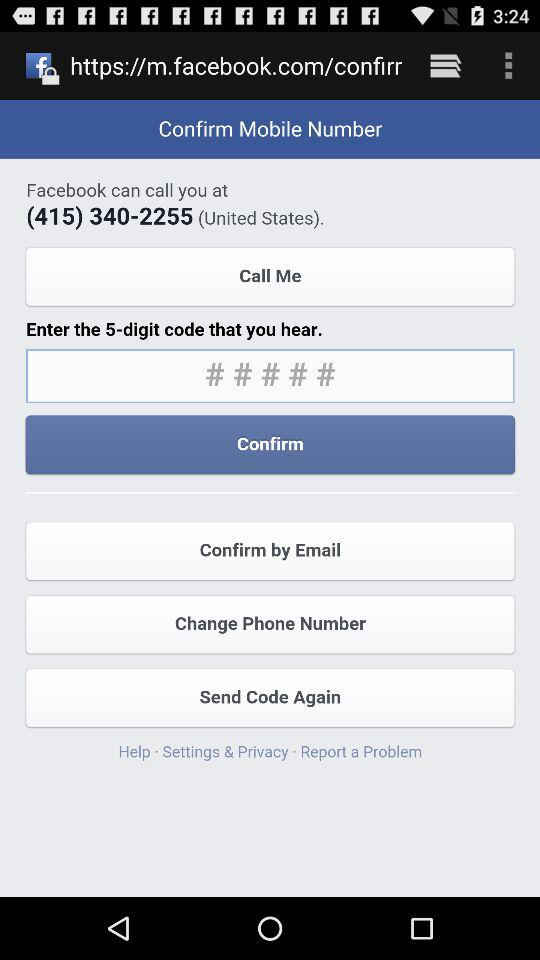How many digits of code did you hear? The digits of the code that you hear are 5. 